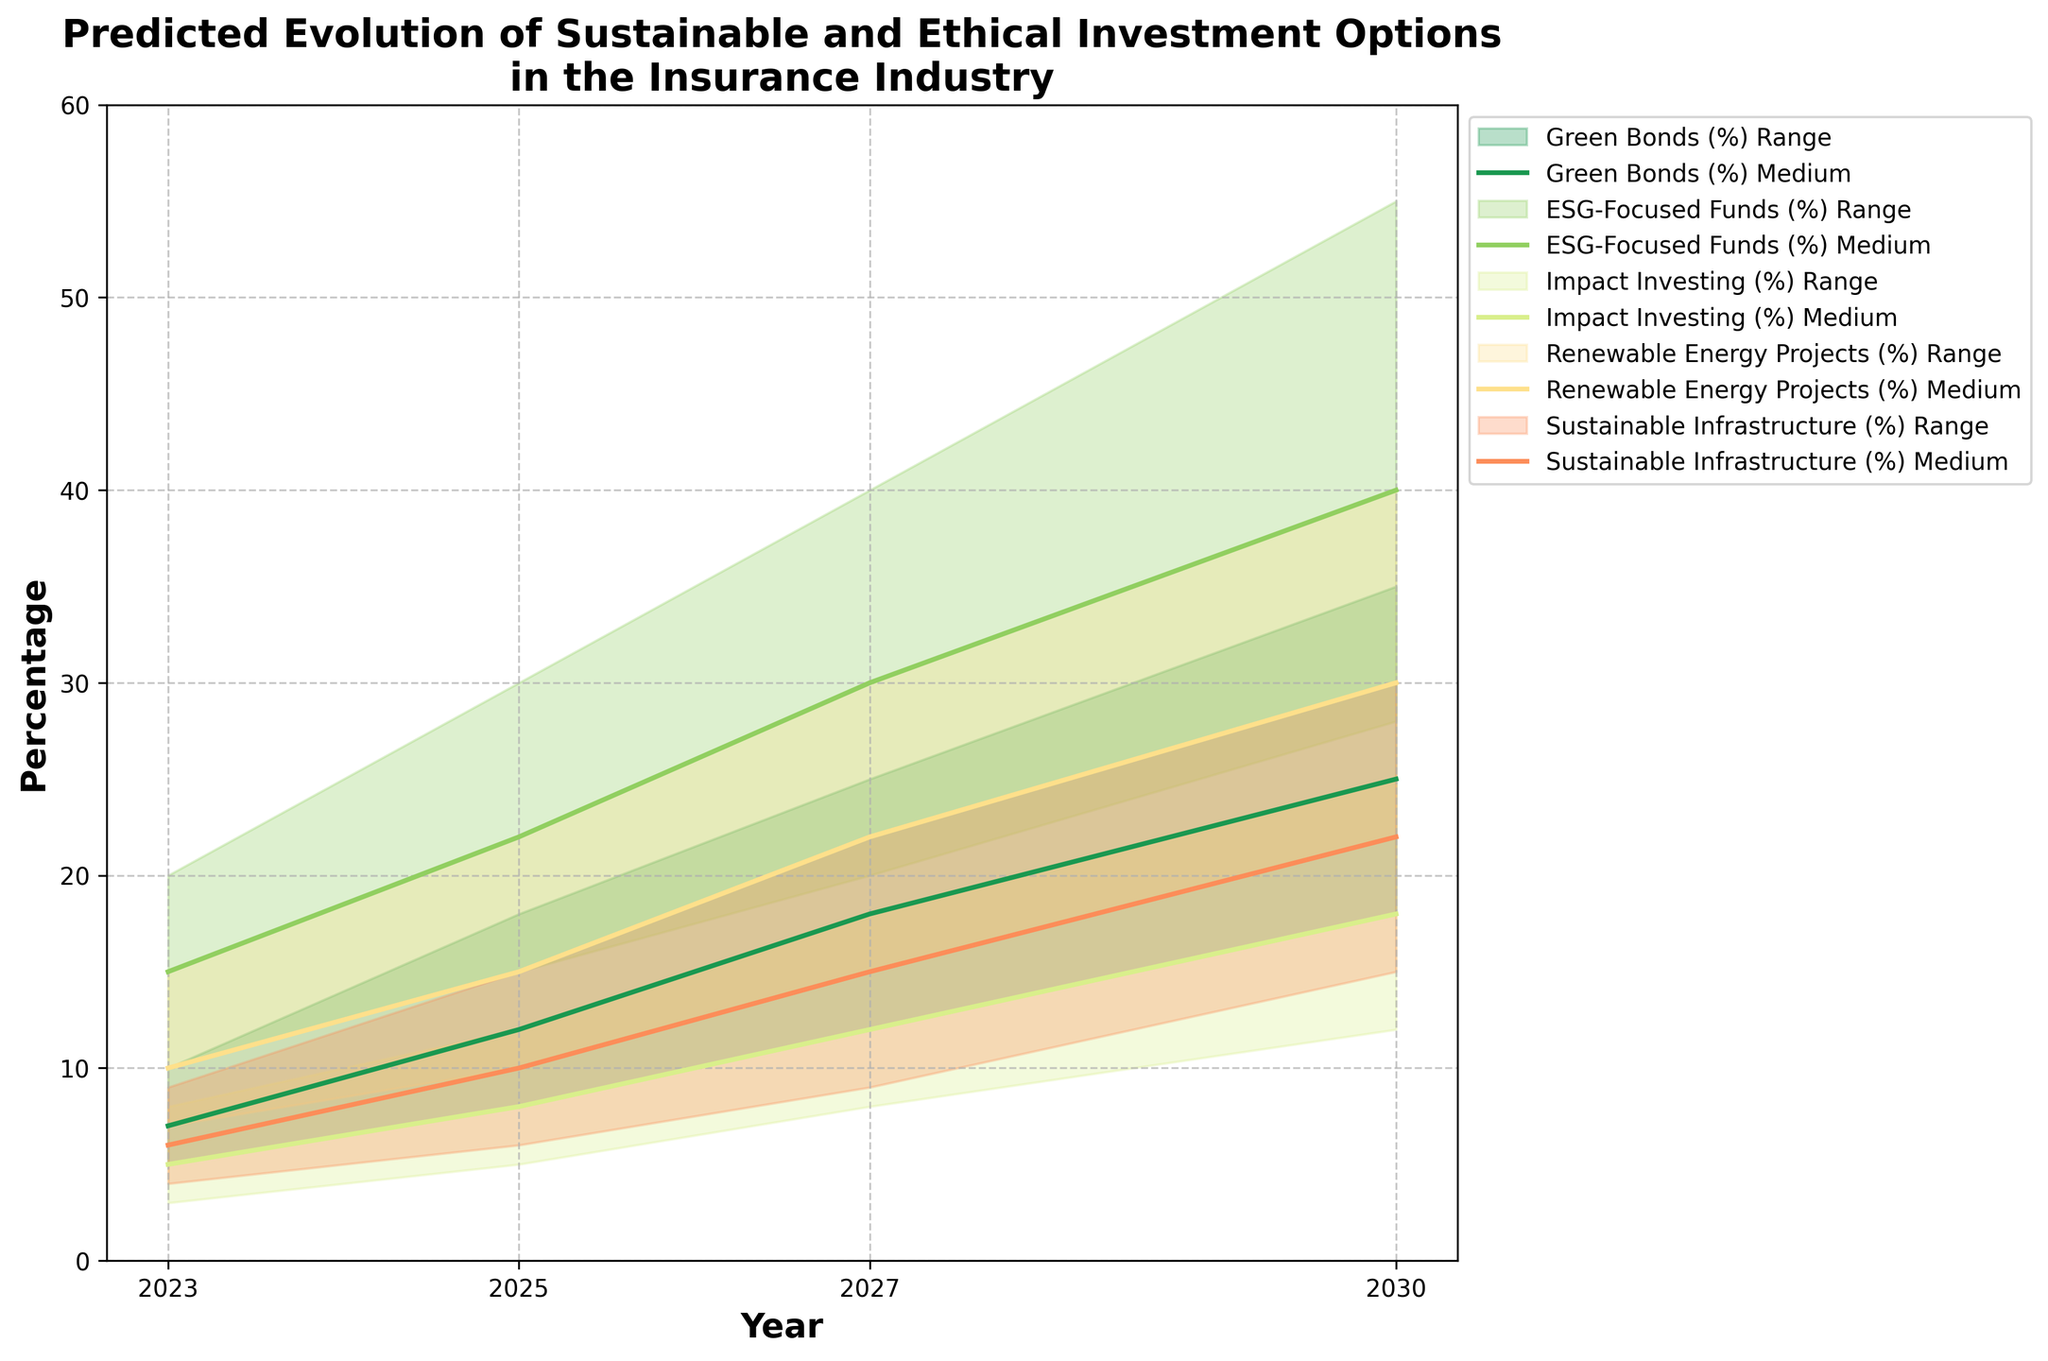What's the title of the figure? The title of the figure is often located at the top and provides a clear description of what the figure represents. In this case, it reads "Predicted Evolution of Sustainable and Ethical Investment Options in the Insurance Industry".
Answer: Predicted Evolution of Sustainable and Ethical Investment Options in the Insurance Industry What is the y-axis representing in this chart? The y-axis label is often a good indicator of what data is being represented. Here, the y-axis is labeled "Percentage", indicating that it shows the percentage values of various investment options.
Answer: Percentage Which sustainable investment option has the highest predicted percentage in 2030 under the 'High' scenario? Looking at the chart, each investment option is color-coded. In 2030 under the 'High' scenario, the 'Green Bonds' data series reaches the highest value, which can be seen from the topmost point of the corresponding shaded area.
Answer: Green Bonds Between which years does 'ESG-Focused Funds' have the largest increase in the 'Medium' scenario? Analyze the plotted lines representing 'ESG-Focused Funds' in the 'Medium' scenario. From 2023 to 2025, there is an increase from 15% to 22%, but from 2025 to 2027, it jumps from 22% to 30%, representing the largest increase.
Answer: 2025 to 2027 What is the difference between the 'High' and 'Low' scenarios for 'Impact Investing' in 2027? Look at the 2027 data points for 'Impact Investing' under both 'High' and 'Low' scenarios. The 'High' scenario reaches 18%, whereas the 'Low' scenario is at 8%. The difference is thus 18% - 8%.
Answer: 10% In which year do 'Renewable Energy Projects' under the 'High' scenario surpass 20%? Analyze the plotted line for 'Renewable Energy Projects' under the 'High' scenario. The line crosses the 20% mark between 2027 and 2030.
Answer: 2030 Comparing the 'Medium' scenario, which investment option shows the least percentage increase from 2023 to 2030? To find the least increase, compare the 2023 and 2030 percentages for each investment option under the 'Medium' scenario. 'Impact Investing' increases from 5% to 18%, which is the smallest increase of 13%.
Answer: Impact Investing What is the predicted percentage range for 'Sustainable Infrastructure' in 2025? For the year 2025, check the shaded area for 'Sustainable Infrastructure' to find the lowest value in the 'Low' scenario and the highest value in the 'High' scenario. These values are 6% and 15%, respectively.
Answer: 6% to 15% Which investment option shows the fastest growth across scenarios between 2023 and 2030? To determine the fastest growth, observe the slopes of lines of each investment option for all scenarios. 'Green Bonds' show the steepest increase across all scenarios from 2023 to 2030.
Answer: Green Bonds 